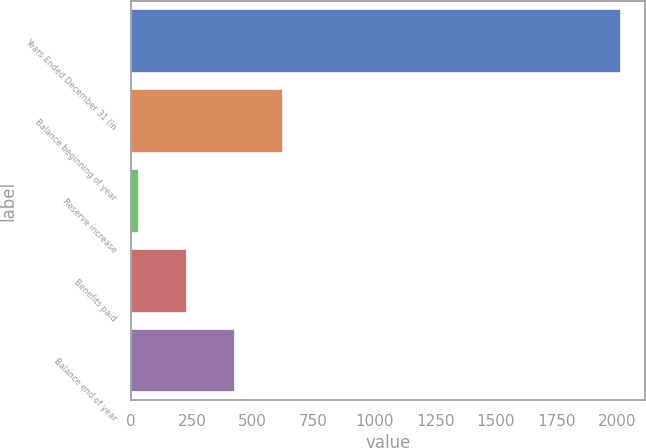<chart> <loc_0><loc_0><loc_500><loc_500><bar_chart><fcel>Years Ended December 31 (in<fcel>Balance beginning of year<fcel>Reserve increase<fcel>Benefits paid<fcel>Balance end of year<nl><fcel>2013<fcel>626.3<fcel>32<fcel>230.1<fcel>428.2<nl></chart> 